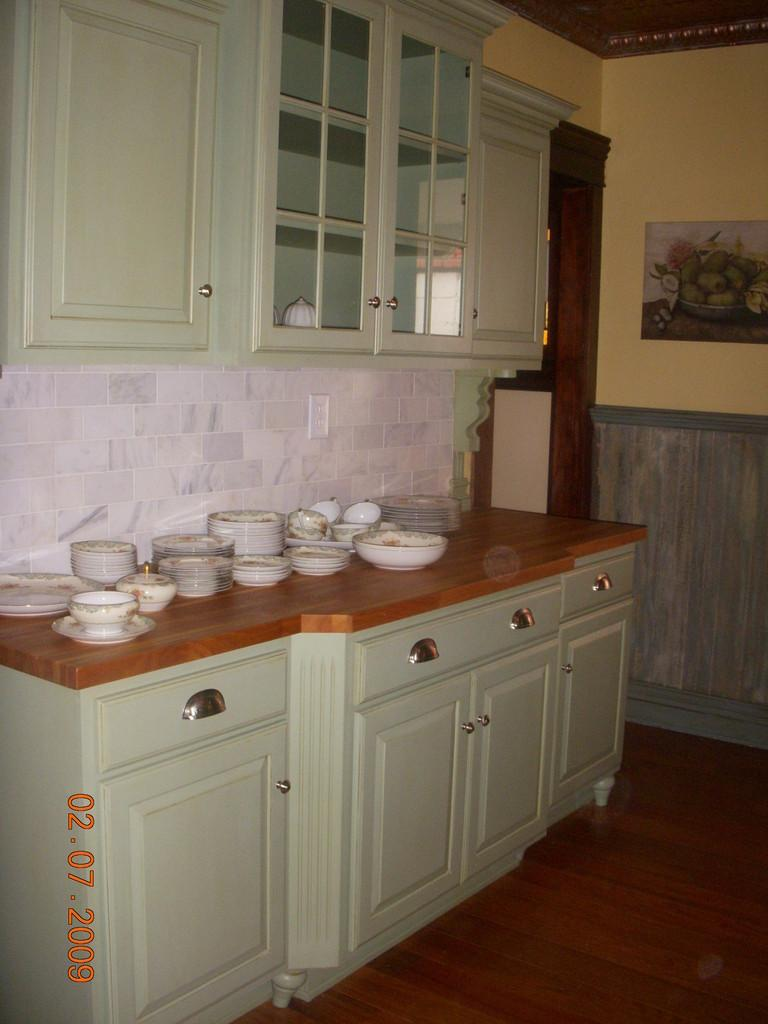What type of furniture is visible in the image? There is a kitchen cabinet in the image. What items can be seen on the cabinet? Plates and bowls are present on the cabinet. What can be seen in the background of the image? There is a wall painting, a window, and a rooftop visible in the background of the image. Where might this image have been taken? The image is likely taken in a room. What type of kitty is sitting on the brick in the image? There is no kitty or brick present in the image. How does the motion of the rooftop change throughout the day in the image? The image is a still photograph, so the motion of the rooftop does not change throughout the day. 